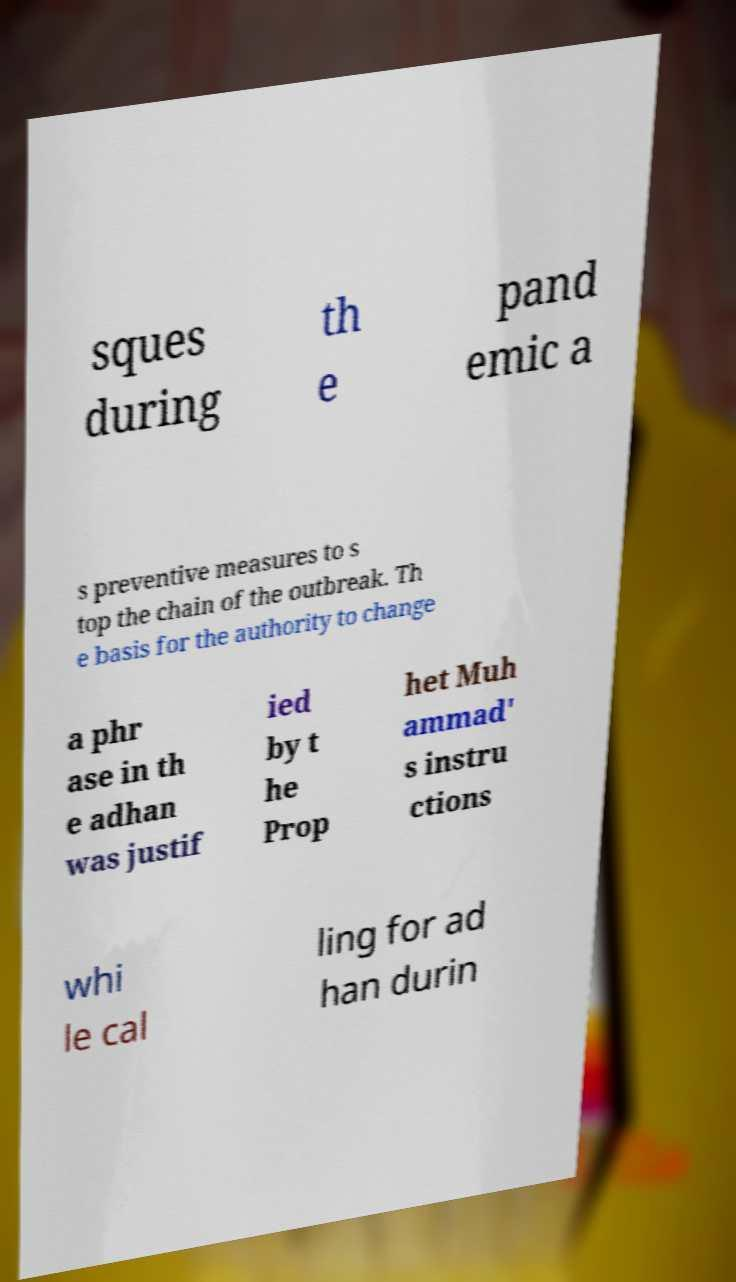Please identify and transcribe the text found in this image. sques during th e pand emic a s preventive measures to s top the chain of the outbreak. Th e basis for the authority to change a phr ase in th e adhan was justif ied by t he Prop het Muh ammad' s instru ctions whi le cal ling for ad han durin 